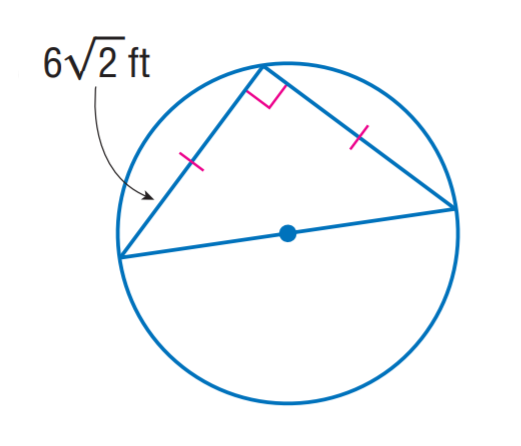Answer the mathemtical geometry problem and directly provide the correct option letter.
Question: The triangle is inscribed into the circle. Find the exact circumference of the circle.
Choices: A: 6 \pi B: 6 \sqrt 2 \pi C: 12 \pi D: 12 \sqrt 2 \pi C 